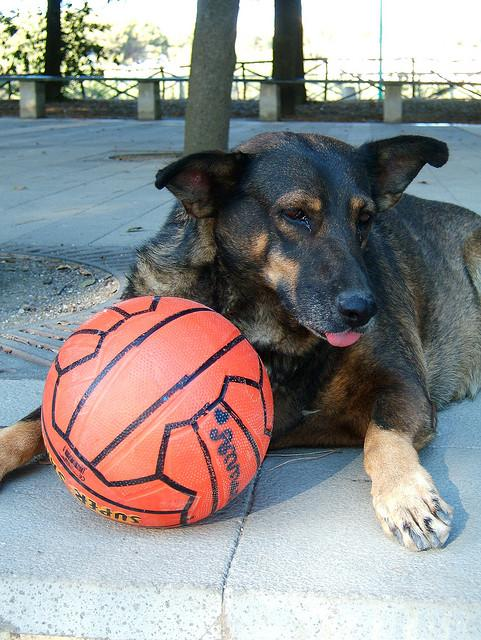What kind of ball is the dog sitting next to on the concrete? Please explain your reasoning. basketball. A canine is laying on the ground with an orange ball in front of it. 